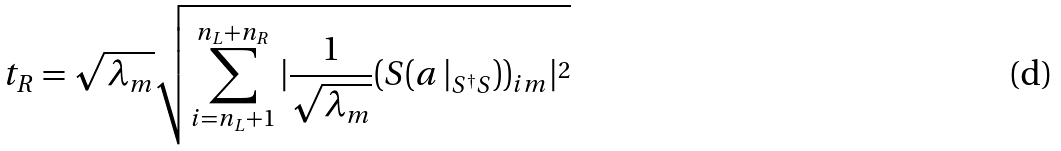<formula> <loc_0><loc_0><loc_500><loc_500>t _ { R } = \sqrt { \lambda _ { m } } \sqrt { \sum _ { i = n _ { L } + 1 } ^ { n _ { L } + n _ { R } } | \frac { 1 } { \sqrt { \lambda _ { m } } } ( S ( { a \, | } _ { S ^ { \dagger } S } ) ) _ { i m } | ^ { 2 } }</formula> 